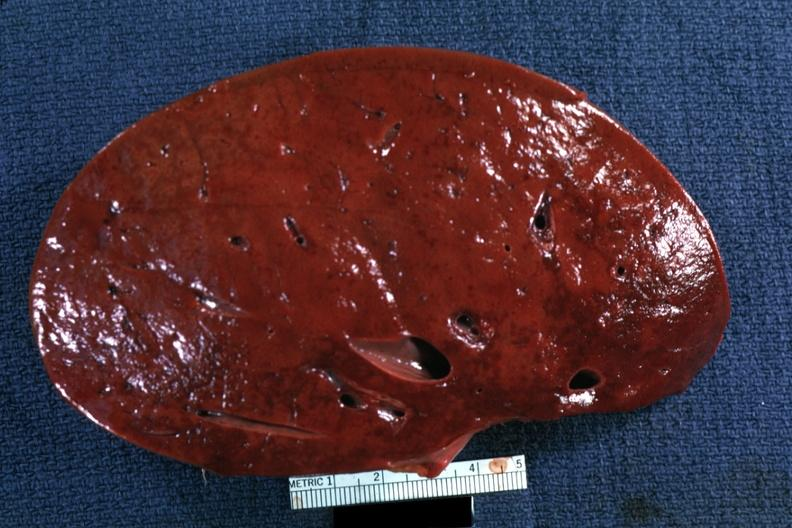s this person had?
Answer the question using a single word or phrase. Yes 